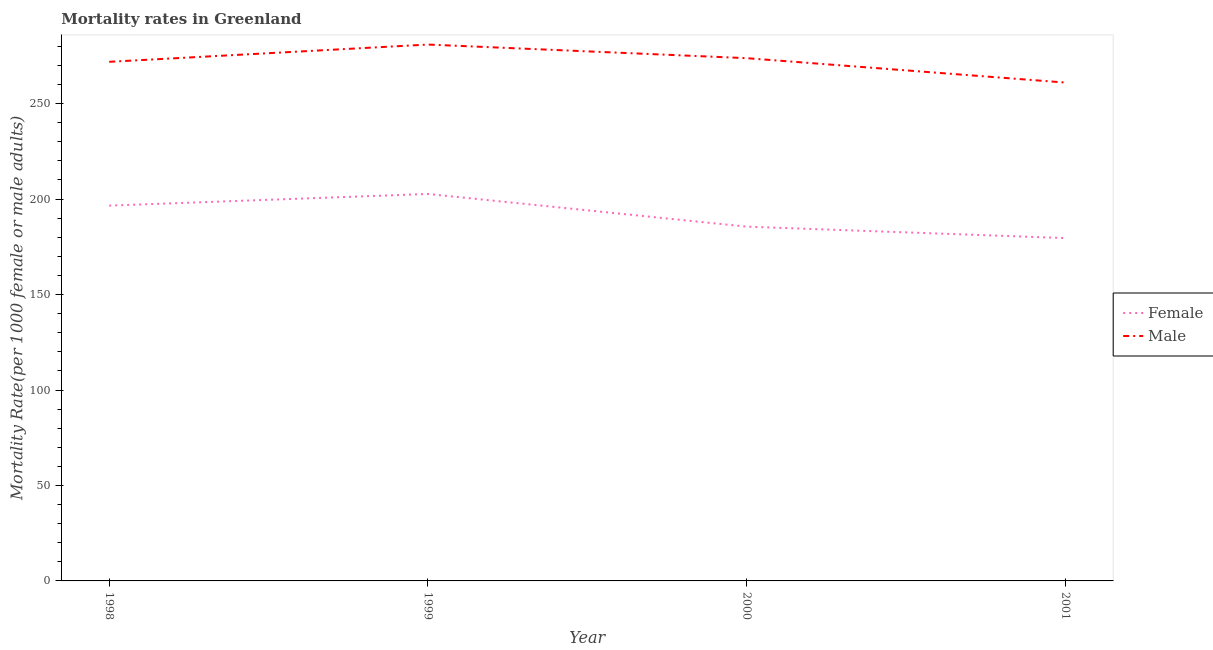How many different coloured lines are there?
Make the answer very short. 2. Does the line corresponding to female mortality rate intersect with the line corresponding to male mortality rate?
Give a very brief answer. No. What is the male mortality rate in 2000?
Provide a short and direct response. 273.81. Across all years, what is the maximum male mortality rate?
Give a very brief answer. 280.94. Across all years, what is the minimum male mortality rate?
Offer a very short reply. 261.03. In which year was the female mortality rate maximum?
Ensure brevity in your answer.  1999. In which year was the male mortality rate minimum?
Give a very brief answer. 2001. What is the total male mortality rate in the graph?
Give a very brief answer. 1087.69. What is the difference between the male mortality rate in 1998 and that in 1999?
Provide a succinct answer. -9.04. What is the difference between the female mortality rate in 1998 and the male mortality rate in 2000?
Your answer should be very brief. -77.23. What is the average male mortality rate per year?
Offer a terse response. 271.92. In the year 1999, what is the difference between the female mortality rate and male mortality rate?
Your response must be concise. -78.26. In how many years, is the female mortality rate greater than 130?
Your response must be concise. 4. What is the ratio of the male mortality rate in 1998 to that in 1999?
Ensure brevity in your answer.  0.97. Is the male mortality rate in 1999 less than that in 2000?
Your answer should be very brief. No. What is the difference between the highest and the second highest male mortality rate?
Your answer should be compact. 7.13. What is the difference between the highest and the lowest male mortality rate?
Ensure brevity in your answer.  19.91. In how many years, is the female mortality rate greater than the average female mortality rate taken over all years?
Provide a succinct answer. 2. Is the sum of the male mortality rate in 1998 and 2000 greater than the maximum female mortality rate across all years?
Keep it short and to the point. Yes. Does the male mortality rate monotonically increase over the years?
Provide a short and direct response. No. How many lines are there?
Your answer should be compact. 2. How many years are there in the graph?
Ensure brevity in your answer.  4. What is the difference between two consecutive major ticks on the Y-axis?
Offer a terse response. 50. Are the values on the major ticks of Y-axis written in scientific E-notation?
Make the answer very short. No. Does the graph contain grids?
Ensure brevity in your answer.  No. Where does the legend appear in the graph?
Provide a succinct answer. Center right. How many legend labels are there?
Offer a very short reply. 2. How are the legend labels stacked?
Your answer should be very brief. Vertical. What is the title of the graph?
Make the answer very short. Mortality rates in Greenland. Does "Primary school" appear as one of the legend labels in the graph?
Provide a succinct answer. No. What is the label or title of the Y-axis?
Provide a succinct answer. Mortality Rate(per 1000 female or male adults). What is the Mortality Rate(per 1000 female or male adults) of Female in 1998?
Offer a terse response. 196.58. What is the Mortality Rate(per 1000 female or male adults) of Male in 1998?
Offer a terse response. 271.9. What is the Mortality Rate(per 1000 female or male adults) in Female in 1999?
Your answer should be very brief. 202.68. What is the Mortality Rate(per 1000 female or male adults) of Male in 1999?
Provide a succinct answer. 280.94. What is the Mortality Rate(per 1000 female or male adults) in Female in 2000?
Provide a short and direct response. 185.57. What is the Mortality Rate(per 1000 female or male adults) of Male in 2000?
Ensure brevity in your answer.  273.81. What is the Mortality Rate(per 1000 female or male adults) of Female in 2001?
Provide a succinct answer. 179.57. What is the Mortality Rate(per 1000 female or male adults) in Male in 2001?
Your response must be concise. 261.03. Across all years, what is the maximum Mortality Rate(per 1000 female or male adults) in Female?
Give a very brief answer. 202.68. Across all years, what is the maximum Mortality Rate(per 1000 female or male adults) in Male?
Keep it short and to the point. 280.94. Across all years, what is the minimum Mortality Rate(per 1000 female or male adults) of Female?
Provide a succinct answer. 179.57. Across all years, what is the minimum Mortality Rate(per 1000 female or male adults) of Male?
Your response must be concise. 261.03. What is the total Mortality Rate(per 1000 female or male adults) in Female in the graph?
Offer a very short reply. 764.39. What is the total Mortality Rate(per 1000 female or male adults) in Male in the graph?
Your answer should be compact. 1087.69. What is the difference between the Mortality Rate(per 1000 female or male adults) in Female in 1998 and that in 1999?
Your answer should be very brief. -6.1. What is the difference between the Mortality Rate(per 1000 female or male adults) in Male in 1998 and that in 1999?
Your answer should be very brief. -9.04. What is the difference between the Mortality Rate(per 1000 female or male adults) in Female in 1998 and that in 2000?
Offer a very short reply. 11.01. What is the difference between the Mortality Rate(per 1000 female or male adults) in Male in 1998 and that in 2000?
Your answer should be compact. -1.91. What is the difference between the Mortality Rate(per 1000 female or male adults) in Female in 1998 and that in 2001?
Give a very brief answer. 17.02. What is the difference between the Mortality Rate(per 1000 female or male adults) of Male in 1998 and that in 2001?
Your answer should be very brief. 10.87. What is the difference between the Mortality Rate(per 1000 female or male adults) of Female in 1999 and that in 2000?
Provide a succinct answer. 17.11. What is the difference between the Mortality Rate(per 1000 female or male adults) of Male in 1999 and that in 2000?
Your answer should be compact. 7.13. What is the difference between the Mortality Rate(per 1000 female or male adults) in Female in 1999 and that in 2001?
Offer a very short reply. 23.11. What is the difference between the Mortality Rate(per 1000 female or male adults) in Male in 1999 and that in 2001?
Your response must be concise. 19.91. What is the difference between the Mortality Rate(per 1000 female or male adults) in Female in 2000 and that in 2001?
Give a very brief answer. 6. What is the difference between the Mortality Rate(per 1000 female or male adults) of Male in 2000 and that in 2001?
Offer a very short reply. 12.78. What is the difference between the Mortality Rate(per 1000 female or male adults) of Female in 1998 and the Mortality Rate(per 1000 female or male adults) of Male in 1999?
Offer a terse response. -84.36. What is the difference between the Mortality Rate(per 1000 female or male adults) in Female in 1998 and the Mortality Rate(per 1000 female or male adults) in Male in 2000?
Your response must be concise. -77.23. What is the difference between the Mortality Rate(per 1000 female or male adults) in Female in 1998 and the Mortality Rate(per 1000 female or male adults) in Male in 2001?
Your answer should be very brief. -64.45. What is the difference between the Mortality Rate(per 1000 female or male adults) in Female in 1999 and the Mortality Rate(per 1000 female or male adults) in Male in 2000?
Provide a succinct answer. -71.13. What is the difference between the Mortality Rate(per 1000 female or male adults) in Female in 1999 and the Mortality Rate(per 1000 female or male adults) in Male in 2001?
Offer a very short reply. -58.35. What is the difference between the Mortality Rate(per 1000 female or male adults) in Female in 2000 and the Mortality Rate(per 1000 female or male adults) in Male in 2001?
Make the answer very short. -75.46. What is the average Mortality Rate(per 1000 female or male adults) in Female per year?
Ensure brevity in your answer.  191.1. What is the average Mortality Rate(per 1000 female or male adults) in Male per year?
Your answer should be very brief. 271.92. In the year 1998, what is the difference between the Mortality Rate(per 1000 female or male adults) in Female and Mortality Rate(per 1000 female or male adults) in Male?
Ensure brevity in your answer.  -75.32. In the year 1999, what is the difference between the Mortality Rate(per 1000 female or male adults) in Female and Mortality Rate(per 1000 female or male adults) in Male?
Provide a succinct answer. -78.26. In the year 2000, what is the difference between the Mortality Rate(per 1000 female or male adults) of Female and Mortality Rate(per 1000 female or male adults) of Male?
Make the answer very short. -88.24. In the year 2001, what is the difference between the Mortality Rate(per 1000 female or male adults) in Female and Mortality Rate(per 1000 female or male adults) in Male?
Make the answer very short. -81.47. What is the ratio of the Mortality Rate(per 1000 female or male adults) of Female in 1998 to that in 1999?
Offer a very short reply. 0.97. What is the ratio of the Mortality Rate(per 1000 female or male adults) in Male in 1998 to that in 1999?
Your answer should be compact. 0.97. What is the ratio of the Mortality Rate(per 1000 female or male adults) of Female in 1998 to that in 2000?
Give a very brief answer. 1.06. What is the ratio of the Mortality Rate(per 1000 female or male adults) of Male in 1998 to that in 2000?
Make the answer very short. 0.99. What is the ratio of the Mortality Rate(per 1000 female or male adults) in Female in 1998 to that in 2001?
Keep it short and to the point. 1.09. What is the ratio of the Mortality Rate(per 1000 female or male adults) in Male in 1998 to that in 2001?
Your answer should be compact. 1.04. What is the ratio of the Mortality Rate(per 1000 female or male adults) of Female in 1999 to that in 2000?
Offer a terse response. 1.09. What is the ratio of the Mortality Rate(per 1000 female or male adults) of Male in 1999 to that in 2000?
Your response must be concise. 1.03. What is the ratio of the Mortality Rate(per 1000 female or male adults) of Female in 1999 to that in 2001?
Make the answer very short. 1.13. What is the ratio of the Mortality Rate(per 1000 female or male adults) in Male in 1999 to that in 2001?
Your answer should be compact. 1.08. What is the ratio of the Mortality Rate(per 1000 female or male adults) of Female in 2000 to that in 2001?
Keep it short and to the point. 1.03. What is the ratio of the Mortality Rate(per 1000 female or male adults) in Male in 2000 to that in 2001?
Offer a terse response. 1.05. What is the difference between the highest and the second highest Mortality Rate(per 1000 female or male adults) of Female?
Your response must be concise. 6.1. What is the difference between the highest and the second highest Mortality Rate(per 1000 female or male adults) of Male?
Make the answer very short. 7.13. What is the difference between the highest and the lowest Mortality Rate(per 1000 female or male adults) of Female?
Offer a very short reply. 23.11. What is the difference between the highest and the lowest Mortality Rate(per 1000 female or male adults) of Male?
Offer a terse response. 19.91. 